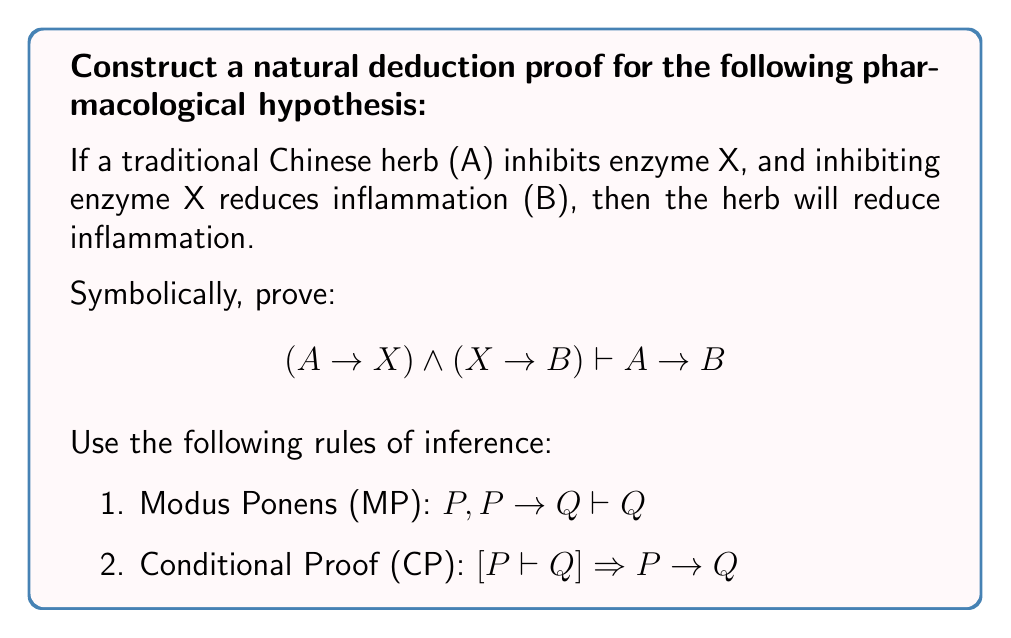Solve this math problem. Let's construct the proof step-by-step using natural deduction:

1. Start with the given premises:
   $$(A \rightarrow X) \land (X \rightarrow B)$$

2. To prove $A \rightarrow B$, we'll use Conditional Proof (CP). Assume $A$ and try to derive $B$:
   
   a. Assume $A$
   
   b. From the first premise, we can extract $A \rightarrow X$
   
   c. Using Modus Ponens (MP) with $A$ and $A \rightarrow X$, we can conclude $X$
   
   d. From the second premise, we can extract $X \rightarrow B$
   
   e. Using Modus Ponens (MP) again with $X$ and $X \rightarrow B$, we can conclude $B$

3. Now that we've derived $B$ from the assumption $A$, we can use Conditional Proof (CP) to conclude $A \rightarrow B$

The formal proof would look like this:

1. $(A \rightarrow X) \land (X \rightarrow B)$ (Premise)
2. $A \rightarrow X$ (Conjunction Elimination, 1)
3. $X \rightarrow B$ (Conjunction Elimination, 1)
4. $A$ (Assumption for CP)
5. $X$ (MP, 2, 4)
6. $B$ (MP, 3, 5)
7. $A \rightarrow B$ (CP, 4-6)

Therefore, we have proven that if a traditional Chinese herb inhibits enzyme X, and inhibiting enzyme X reduces inflammation, then the herb will reduce inflammation.
Answer: $$(A \rightarrow X) \land (X \rightarrow B) \vdash A \rightarrow B$$ 